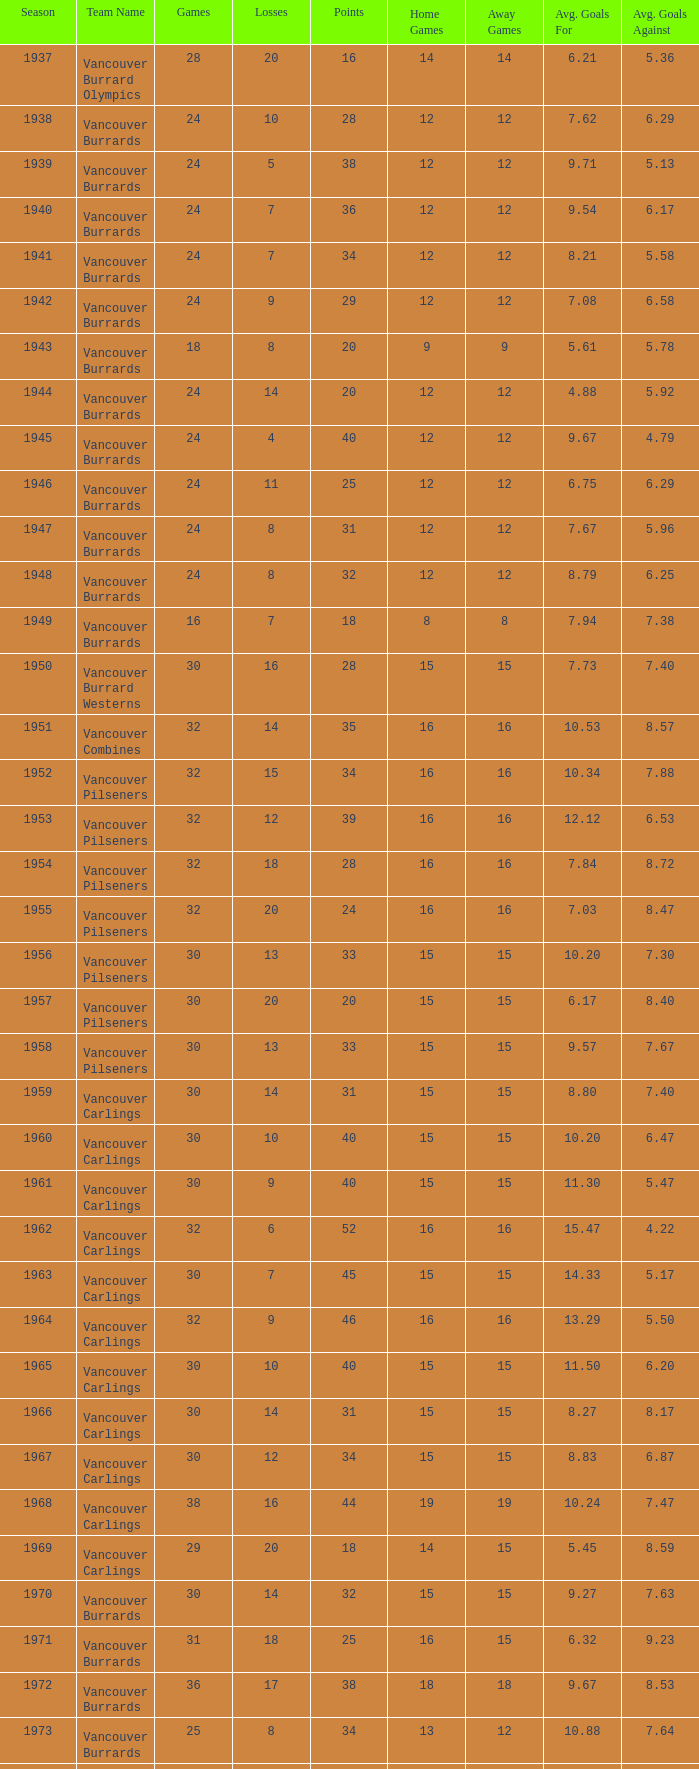What's the total number of games with more than 20 points for the 1976 season? 0.0. 